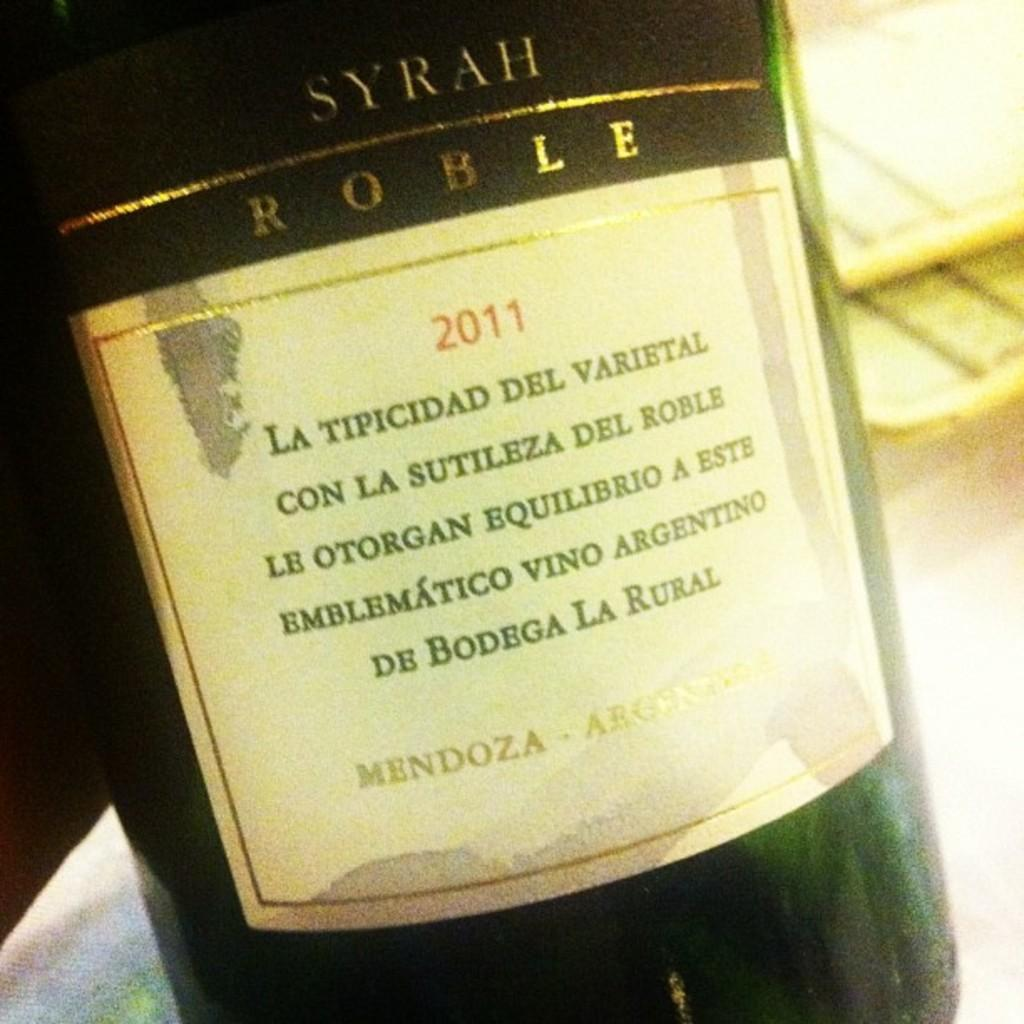What is the main object in the image? There is a wine bottle in the image. What can be seen on the wine bottle? The wine bottle has a label on it. Can you describe the background of the image? The background of the image is blurred. Is there a quill being used to write on the wine bottle label in the image? There is no quill present in the image, and the label on the wine bottle does not show any signs of being written on with a quill. 